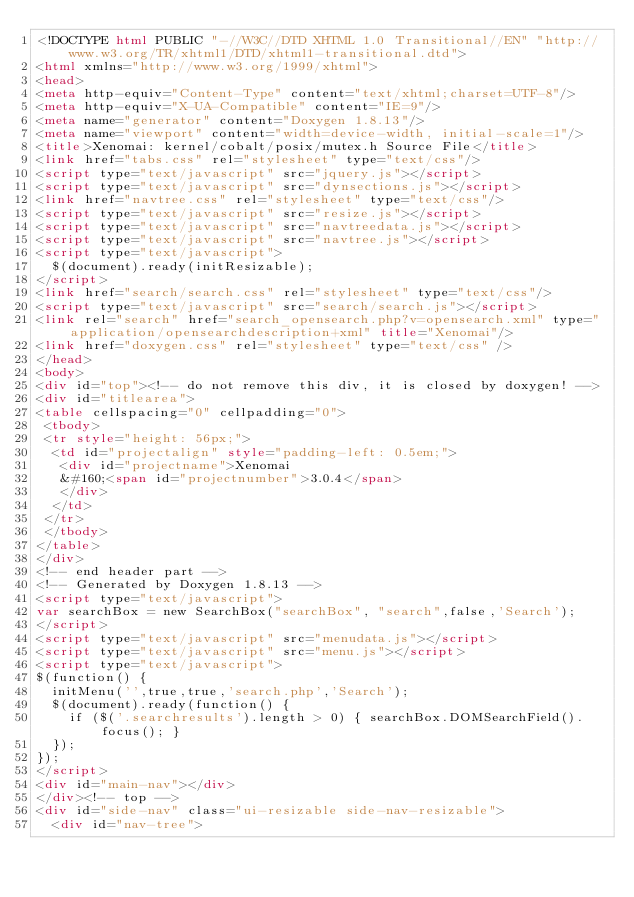<code> <loc_0><loc_0><loc_500><loc_500><_HTML_><!DOCTYPE html PUBLIC "-//W3C//DTD XHTML 1.0 Transitional//EN" "http://www.w3.org/TR/xhtml1/DTD/xhtml1-transitional.dtd">
<html xmlns="http://www.w3.org/1999/xhtml">
<head>
<meta http-equiv="Content-Type" content="text/xhtml;charset=UTF-8"/>
<meta http-equiv="X-UA-Compatible" content="IE=9"/>
<meta name="generator" content="Doxygen 1.8.13"/>
<meta name="viewport" content="width=device-width, initial-scale=1"/>
<title>Xenomai: kernel/cobalt/posix/mutex.h Source File</title>
<link href="tabs.css" rel="stylesheet" type="text/css"/>
<script type="text/javascript" src="jquery.js"></script>
<script type="text/javascript" src="dynsections.js"></script>
<link href="navtree.css" rel="stylesheet" type="text/css"/>
<script type="text/javascript" src="resize.js"></script>
<script type="text/javascript" src="navtreedata.js"></script>
<script type="text/javascript" src="navtree.js"></script>
<script type="text/javascript">
  $(document).ready(initResizable);
</script>
<link href="search/search.css" rel="stylesheet" type="text/css"/>
<script type="text/javascript" src="search/search.js"></script>
<link rel="search" href="search_opensearch.php?v=opensearch.xml" type="application/opensearchdescription+xml" title="Xenomai"/>
<link href="doxygen.css" rel="stylesheet" type="text/css" />
</head>
<body>
<div id="top"><!-- do not remove this div, it is closed by doxygen! -->
<div id="titlearea">
<table cellspacing="0" cellpadding="0">
 <tbody>
 <tr style="height: 56px;">
  <td id="projectalign" style="padding-left: 0.5em;">
   <div id="projectname">Xenomai
   &#160;<span id="projectnumber">3.0.4</span>
   </div>
  </td>
 </tr>
 </tbody>
</table>
</div>
<!-- end header part -->
<!-- Generated by Doxygen 1.8.13 -->
<script type="text/javascript">
var searchBox = new SearchBox("searchBox", "search",false,'Search');
</script>
<script type="text/javascript" src="menudata.js"></script>
<script type="text/javascript" src="menu.js"></script>
<script type="text/javascript">
$(function() {
  initMenu('',true,true,'search.php','Search');
  $(document).ready(function() {
    if ($('.searchresults').length > 0) { searchBox.DOMSearchField().focus(); }
  });
});
</script>
<div id="main-nav"></div>
</div><!-- top -->
<div id="side-nav" class="ui-resizable side-nav-resizable">
  <div id="nav-tree"></code> 